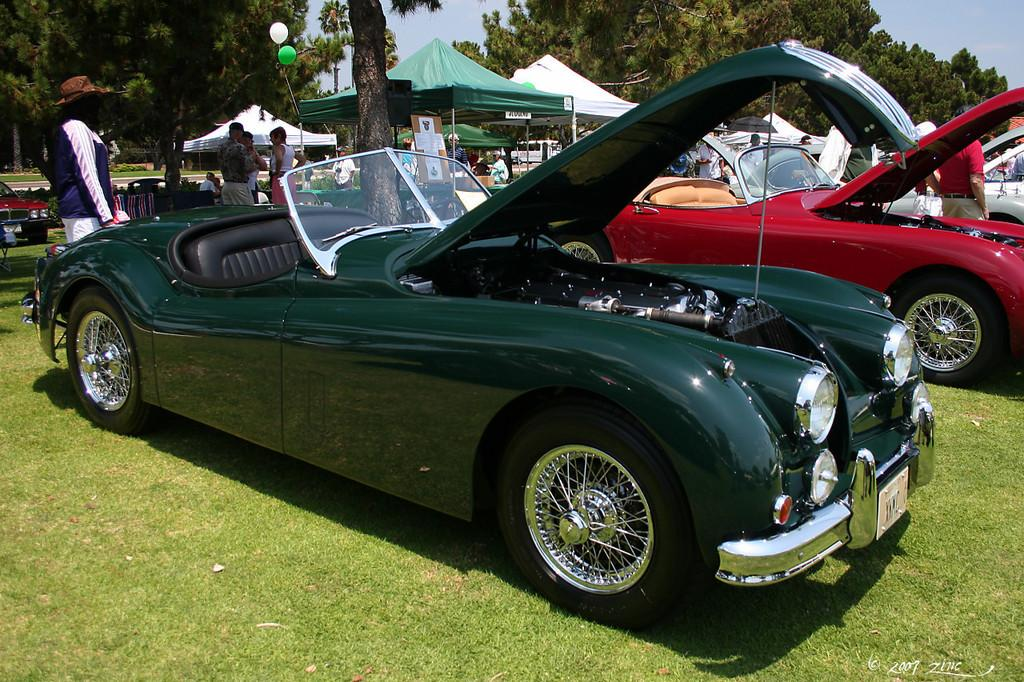What is the main subject in the center of the image? There are cars in the center of the image. What can be seen in the background of the image? There are trees in the background of the image. What type of temporary shelter is present in the image? There are tents in the image. What type of ground surface is visible at the bottom of the image? There is grass at the bottom of the image. What grade of paint is used on the face of the person in the image? There is no person or paint visible in the image; it features cars, trees, tents, and grass. 